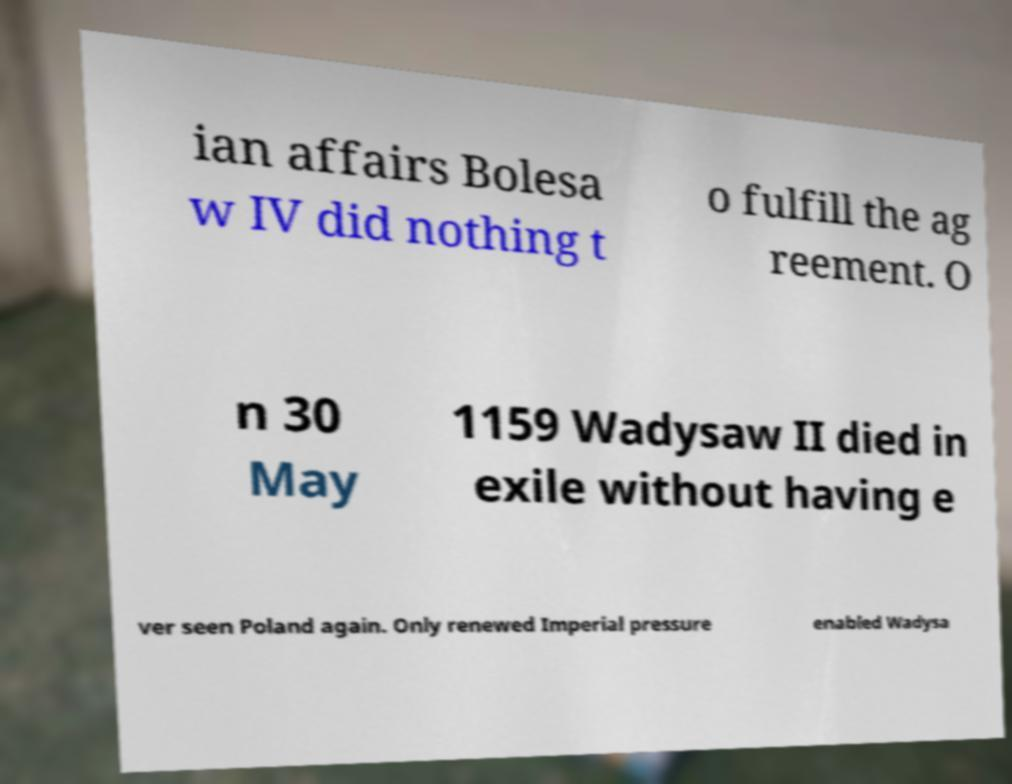Can you accurately transcribe the text from the provided image for me? ian affairs Bolesa w IV did nothing t o fulfill the ag reement. O n 30 May 1159 Wadysaw II died in exile without having e ver seen Poland again. Only renewed Imperial pressure enabled Wadysa 